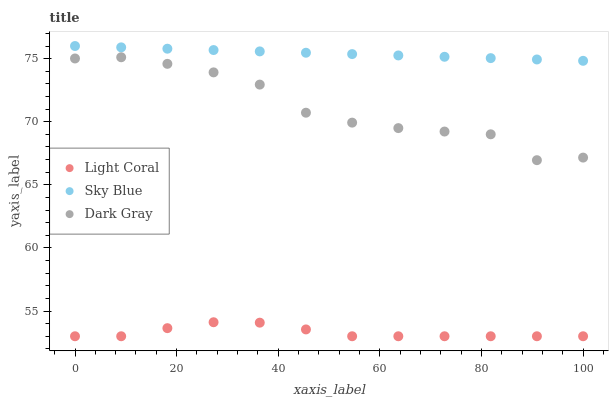Does Light Coral have the minimum area under the curve?
Answer yes or no. Yes. Does Sky Blue have the maximum area under the curve?
Answer yes or no. Yes. Does Dark Gray have the minimum area under the curve?
Answer yes or no. No. Does Dark Gray have the maximum area under the curve?
Answer yes or no. No. Is Sky Blue the smoothest?
Answer yes or no. Yes. Is Dark Gray the roughest?
Answer yes or no. Yes. Is Dark Gray the smoothest?
Answer yes or no. No. Is Sky Blue the roughest?
Answer yes or no. No. Does Light Coral have the lowest value?
Answer yes or no. Yes. Does Dark Gray have the lowest value?
Answer yes or no. No. Does Sky Blue have the highest value?
Answer yes or no. Yes. Does Dark Gray have the highest value?
Answer yes or no. No. Is Dark Gray less than Sky Blue?
Answer yes or no. Yes. Is Sky Blue greater than Light Coral?
Answer yes or no. Yes. Does Dark Gray intersect Sky Blue?
Answer yes or no. No. 